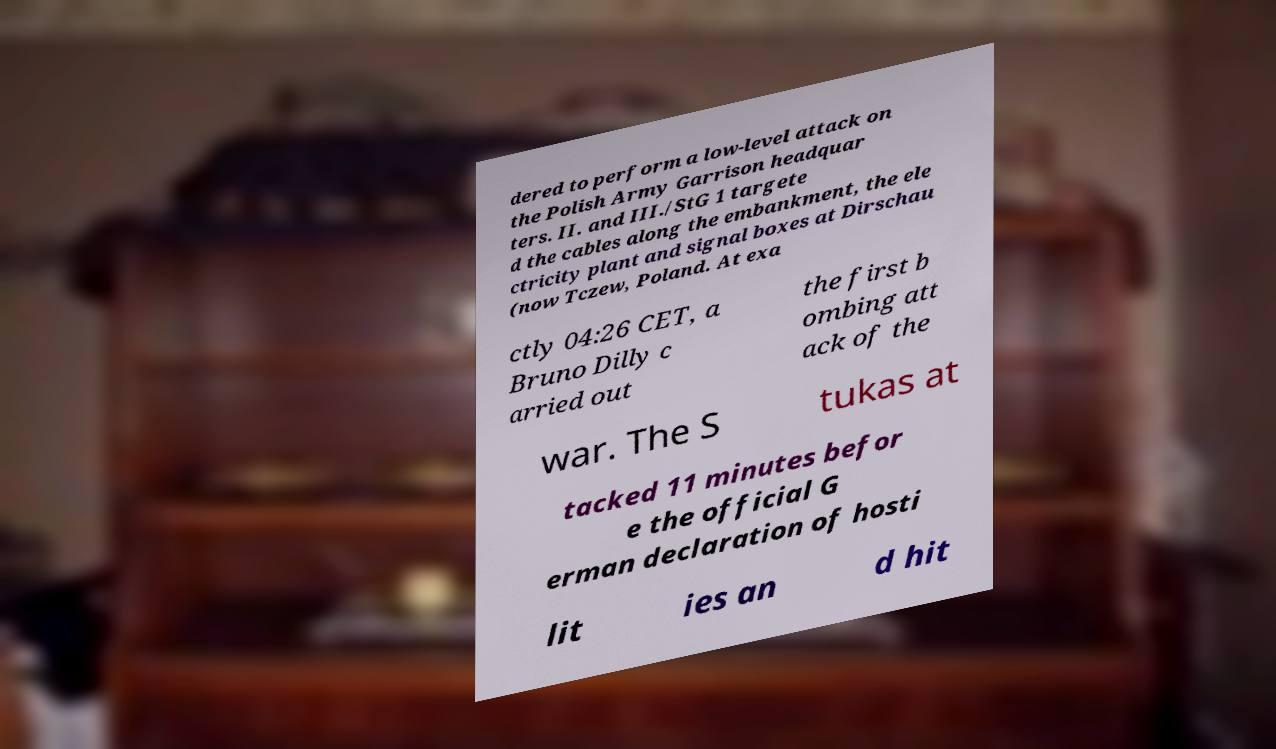Can you accurately transcribe the text from the provided image for me? dered to perform a low-level attack on the Polish Army Garrison headquar ters. II. and III./StG 1 targete d the cables along the embankment, the ele ctricity plant and signal boxes at Dirschau (now Tczew, Poland. At exa ctly 04:26 CET, a Bruno Dilly c arried out the first b ombing att ack of the war. The S tukas at tacked 11 minutes befor e the official G erman declaration of hosti lit ies an d hit 